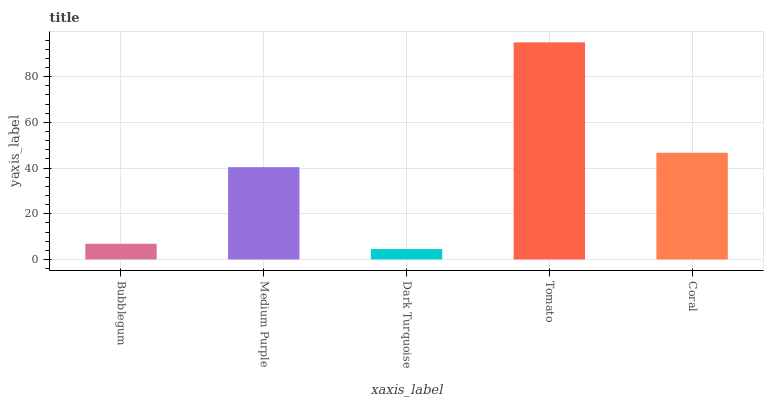Is Dark Turquoise the minimum?
Answer yes or no. Yes. Is Tomato the maximum?
Answer yes or no. Yes. Is Medium Purple the minimum?
Answer yes or no. No. Is Medium Purple the maximum?
Answer yes or no. No. Is Medium Purple greater than Bubblegum?
Answer yes or no. Yes. Is Bubblegum less than Medium Purple?
Answer yes or no. Yes. Is Bubblegum greater than Medium Purple?
Answer yes or no. No. Is Medium Purple less than Bubblegum?
Answer yes or no. No. Is Medium Purple the high median?
Answer yes or no. Yes. Is Medium Purple the low median?
Answer yes or no. Yes. Is Bubblegum the high median?
Answer yes or no. No. Is Tomato the low median?
Answer yes or no. No. 